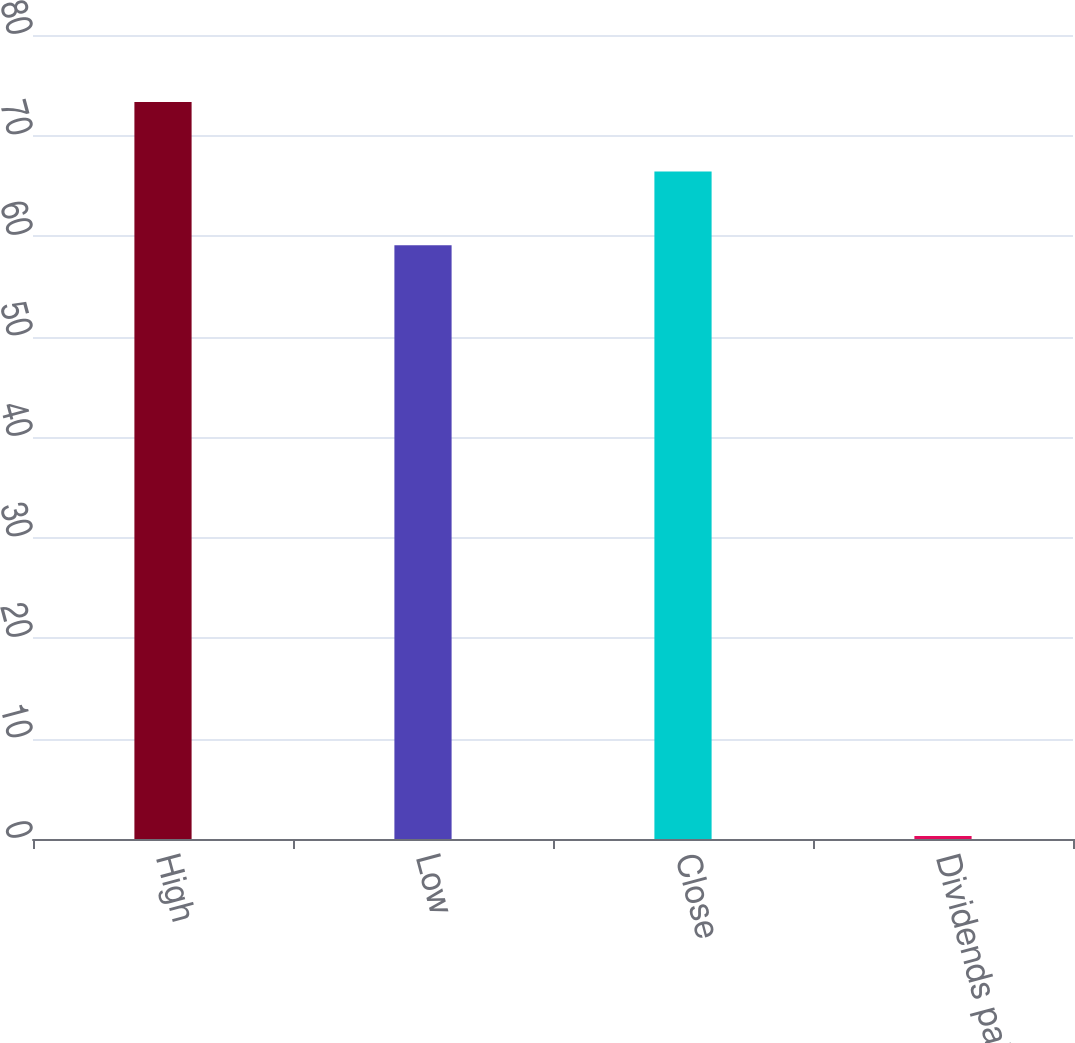<chart> <loc_0><loc_0><loc_500><loc_500><bar_chart><fcel>High<fcel>Low<fcel>Close<fcel>Dividends paid<nl><fcel>73.33<fcel>59.09<fcel>66.42<fcel>0.3<nl></chart> 